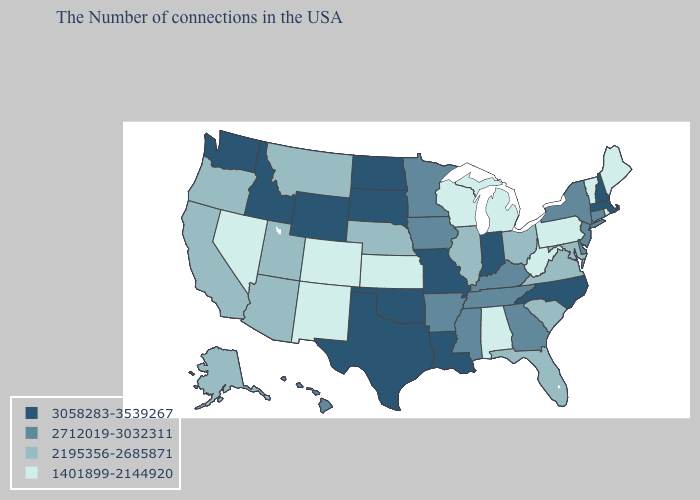Which states hav the highest value in the Northeast?
Give a very brief answer. Massachusetts, New Hampshire. Among the states that border Texas , does New Mexico have the lowest value?
Short answer required. Yes. Does Washington have the highest value in the West?
Be succinct. Yes. Does Oklahoma have the highest value in the USA?
Answer briefly. Yes. What is the value of Iowa?
Concise answer only. 2712019-3032311. Name the states that have a value in the range 2195356-2685871?
Keep it brief. Maryland, Virginia, South Carolina, Ohio, Florida, Illinois, Nebraska, Utah, Montana, Arizona, California, Oregon, Alaska. What is the value of Idaho?
Keep it brief. 3058283-3539267. What is the highest value in the West ?
Be succinct. 3058283-3539267. Which states have the highest value in the USA?
Give a very brief answer. Massachusetts, New Hampshire, North Carolina, Indiana, Louisiana, Missouri, Oklahoma, Texas, South Dakota, North Dakota, Wyoming, Idaho, Washington. Name the states that have a value in the range 2195356-2685871?
Be succinct. Maryland, Virginia, South Carolina, Ohio, Florida, Illinois, Nebraska, Utah, Montana, Arizona, California, Oregon, Alaska. Which states hav the highest value in the MidWest?
Write a very short answer. Indiana, Missouri, South Dakota, North Dakota. What is the lowest value in the USA?
Write a very short answer. 1401899-2144920. Name the states that have a value in the range 3058283-3539267?
Concise answer only. Massachusetts, New Hampshire, North Carolina, Indiana, Louisiana, Missouri, Oklahoma, Texas, South Dakota, North Dakota, Wyoming, Idaho, Washington. Among the states that border Minnesota , which have the lowest value?
Short answer required. Wisconsin. Name the states that have a value in the range 3058283-3539267?
Short answer required. Massachusetts, New Hampshire, North Carolina, Indiana, Louisiana, Missouri, Oklahoma, Texas, South Dakota, North Dakota, Wyoming, Idaho, Washington. 